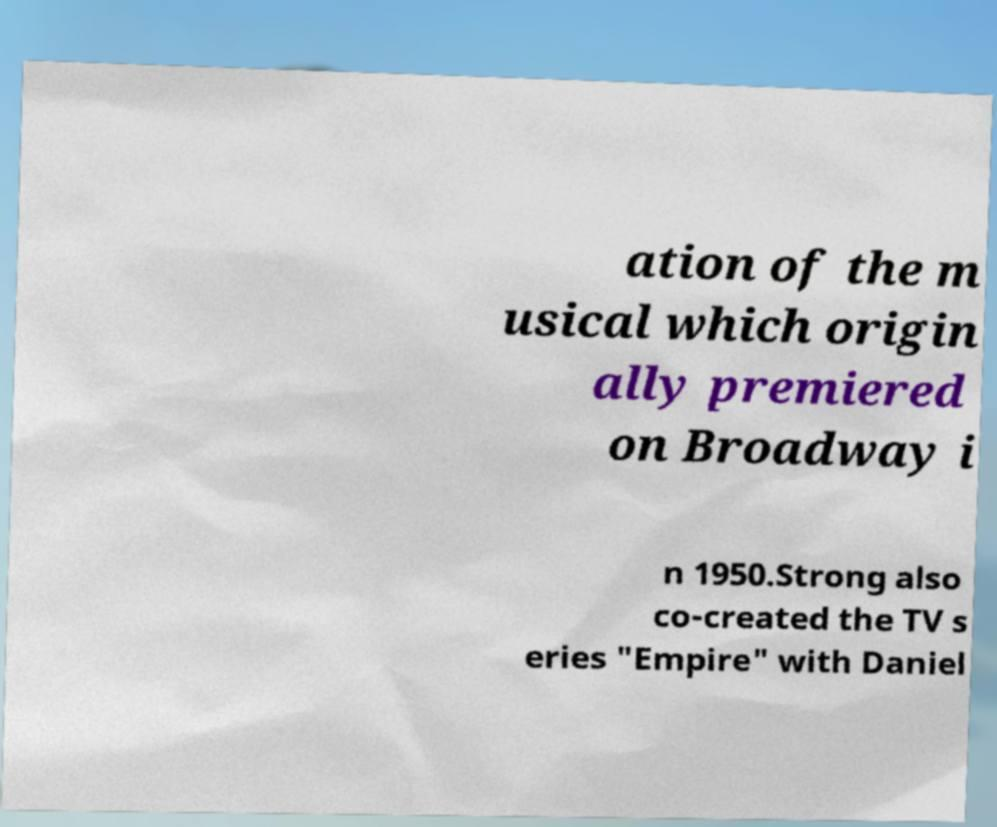Please read and relay the text visible in this image. What does it say? ation of the m usical which origin ally premiered on Broadway i n 1950.Strong also co-created the TV s eries "Empire" with Daniel 